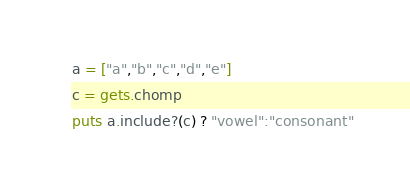<code> <loc_0><loc_0><loc_500><loc_500><_Ruby_>a = ["a","b","c","d","e"]
c = gets.chomp
puts a.include?(c) ? "vowel":"consonant"
</code> 